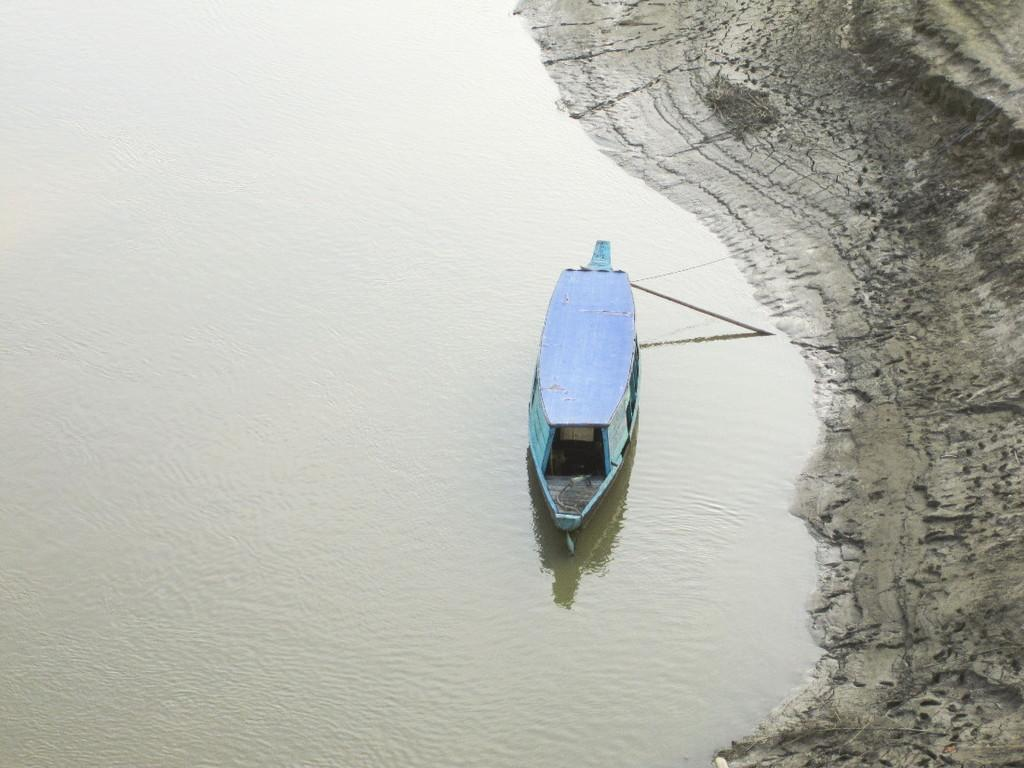What is the main subject of the image? The main subject of the image is a boat. Where is the boat located? The boat is in the water. What color is the boat? The boat is blue in color. What type of terrain can be seen in the image? There is mud visible in the image. Can you tell me how many goats are standing on the boat in the image? There are no goats present in the image; it features a blue boat in the water. What type of stem can be seen growing from the boat in the image? There is no stem growing from the boat in the image; it is a blue boat in the water with no visible plants or stems. 